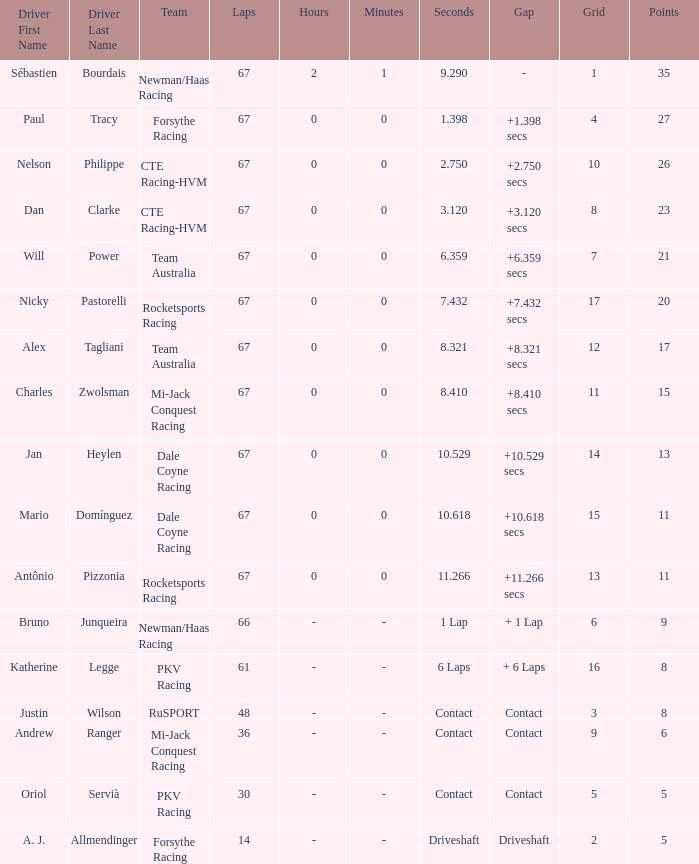How many average laps for Alex Tagliani with more than 17 points? None. 